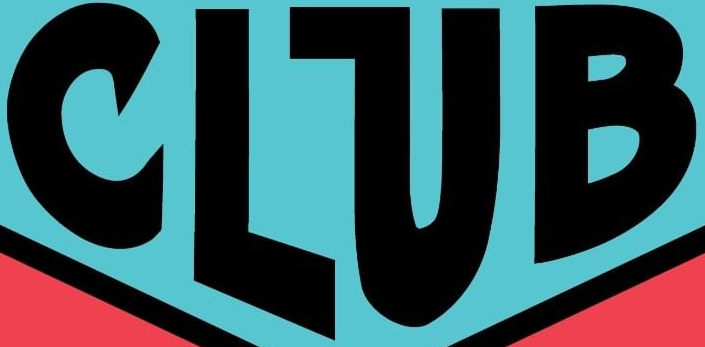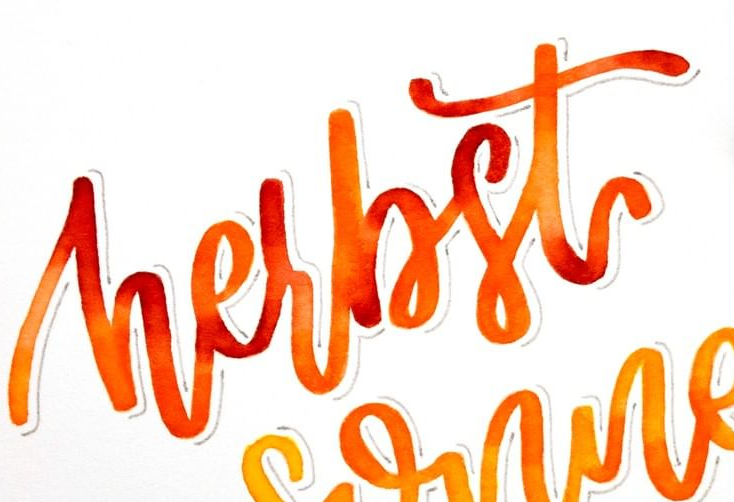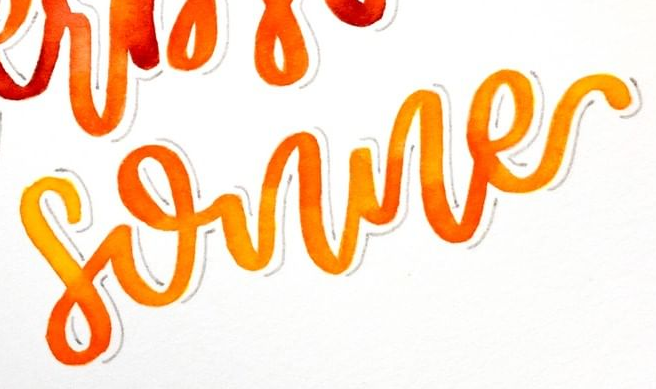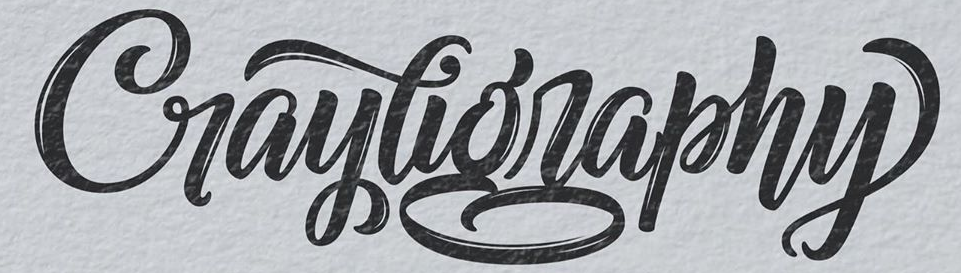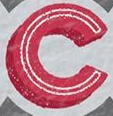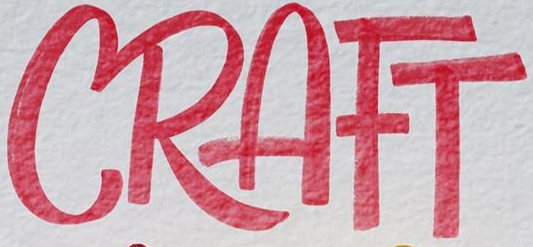Identify the words shown in these images in order, separated by a semicolon. CLUB; hesbst; sonne; Craytigraphy; C; CRAFT 